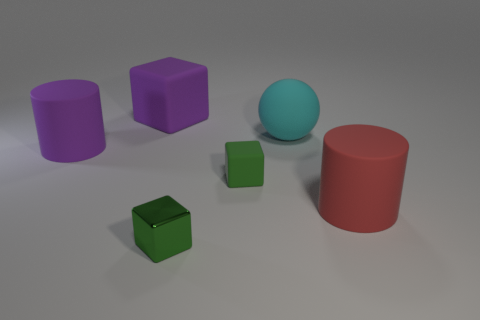Subtract all green balls. Subtract all brown cylinders. How many balls are left? 1 Subtract all brown spheres. How many cyan cubes are left? 0 Add 5 big reds. How many large purples exist? 0 Subtract all large purple cylinders. Subtract all tiny green matte blocks. How many objects are left? 4 Add 4 tiny rubber objects. How many tiny rubber objects are left? 5 Add 3 blocks. How many blocks exist? 6 Add 4 small cyan metallic cylinders. How many objects exist? 10 Subtract all green cubes. How many cubes are left? 1 Subtract all metal cubes. How many cubes are left? 2 Subtract 0 blue balls. How many objects are left? 6 